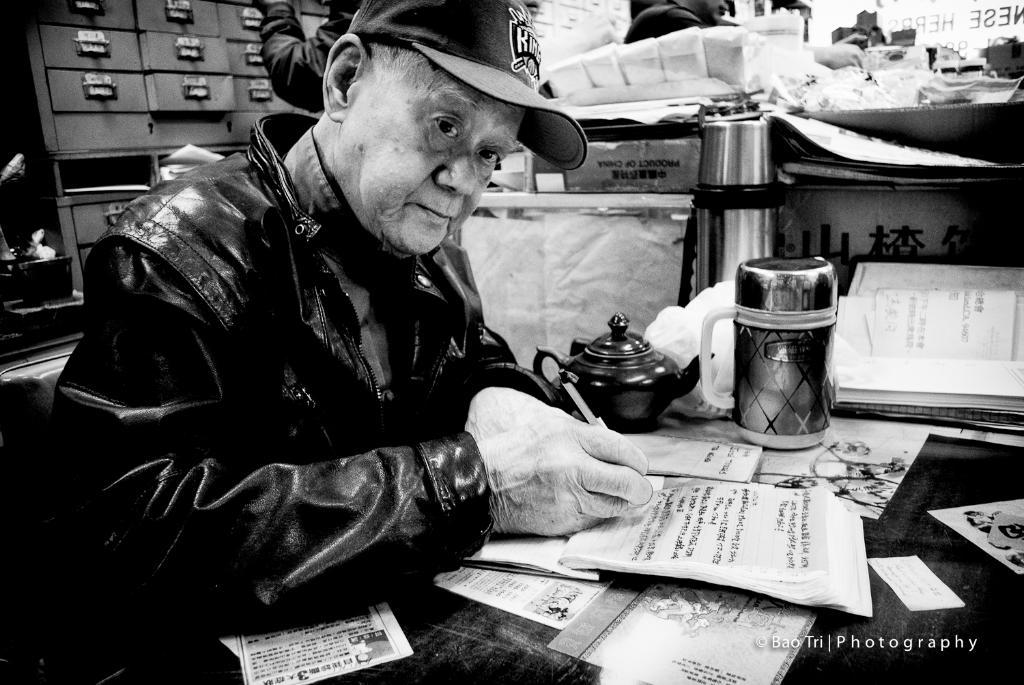What is the color scheme of the image? The image is black and white. What is the person in the image doing? The person is writing in a book. What is present on the table in the image? There is a table in the image with books, a kettle, a flask, papers, and a jar on it. How is the rake being used in the image? There is no rake present in the image. What is the distribution of the books on the table? The books are not being distributed in the image; they are simply present on the table. Did the earthquake cause any damage to the items on the table in the image? There is no indication of an earthquake or any damage to the items in the image. 